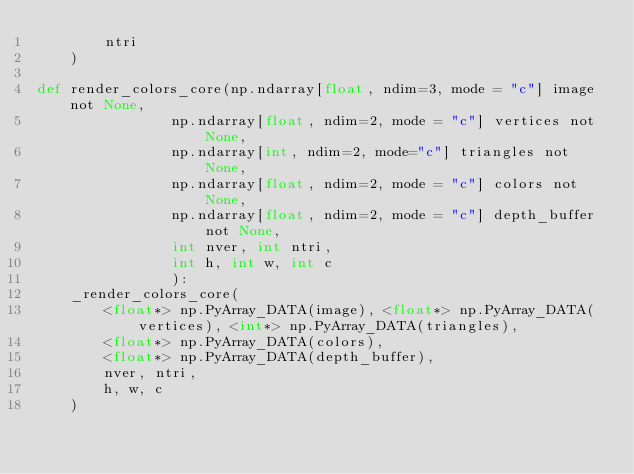<code> <loc_0><loc_0><loc_500><loc_500><_Cython_>        ntri
    )

def render_colors_core(np.ndarray[float, ndim=3, mode = "c"] image not None,
                np.ndarray[float, ndim=2, mode = "c"] vertices not None,
                np.ndarray[int, ndim=2, mode="c"] triangles not None,
                np.ndarray[float, ndim=2, mode = "c"] colors not None,
                np.ndarray[float, ndim=2, mode = "c"] depth_buffer not None,
                int nver, int ntri,
                int h, int w, int c
                ):
    _render_colors_core(
        <float*> np.PyArray_DATA(image), <float*> np.PyArray_DATA(vertices), <int*> np.PyArray_DATA(triangles),
        <float*> np.PyArray_DATA(colors),
        <float*> np.PyArray_DATA(depth_buffer),
        nver, ntri,
        h, w, c
    )</code> 